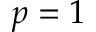<formula> <loc_0><loc_0><loc_500><loc_500>p = 1</formula> 